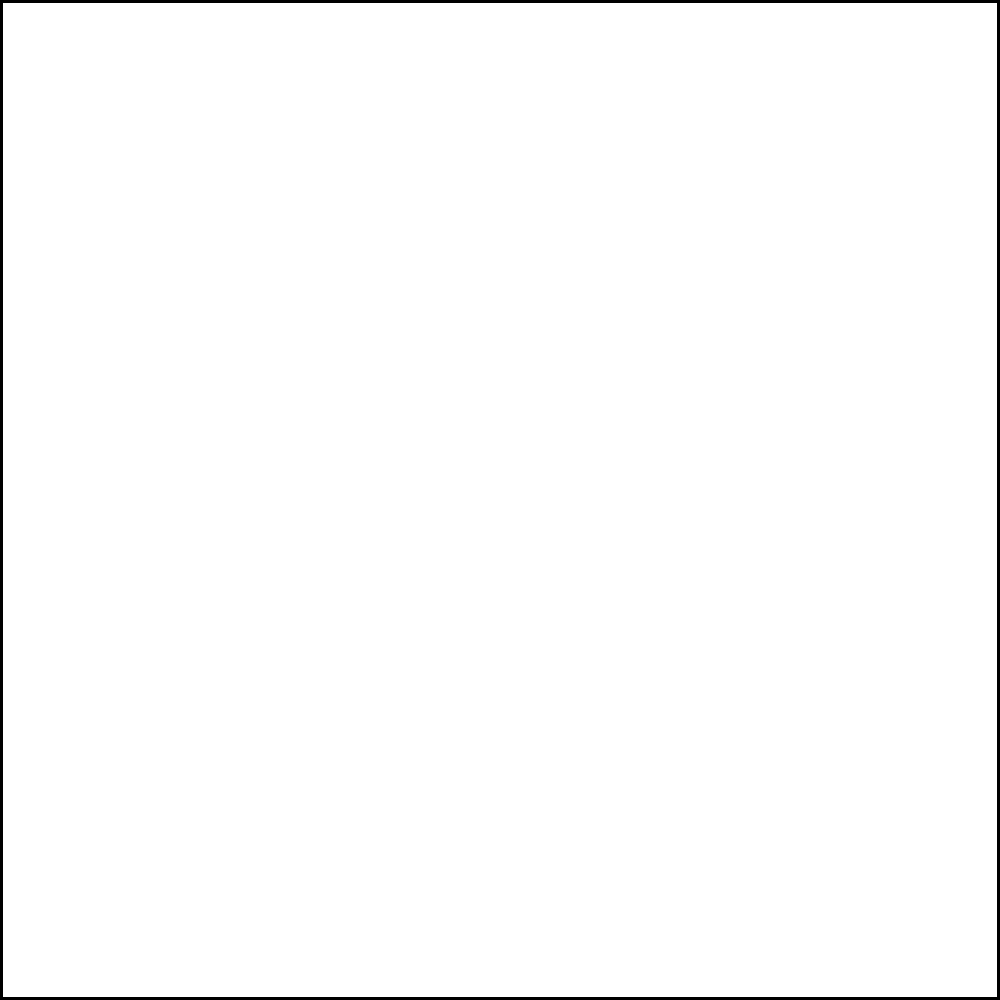A railway curve needs to be designed to connect two straight track sections at a right angle. Given that the minimum radius of curvature for safe passage is 500 meters and the total length of the curve is 785 meters, what is the minimum turning angle (in degrees) required for this railway curve? To solve this problem, we'll follow these steps:

1) First, recall the formula for the length of an arc:
   $L = R\theta$
   Where $L$ is the length of the arc, $R$ is the radius, and $\theta$ is the angle in radians.

2) We're given:
   $R = 500$ meters
   $L = 785$ meters

3) Substitute these values into the formula:
   $785 = 500\theta$

4) Solve for $\theta$:
   $\theta = \frac{785}{500} = 1.57$ radians

5) Convert radians to degrees:
   $\theta_{degrees} = \theta_{radians} \times \frac{180}{\pi}$
   $\theta_{degrees} = 1.57 \times \frac{180}{\pi} \approx 90°$

6) The question asks for the minimum turning angle. In a right-angled turn (90°), the curve needs to turn through 90°.

Therefore, the minimum turning angle required is 90°.
Answer: 90° 